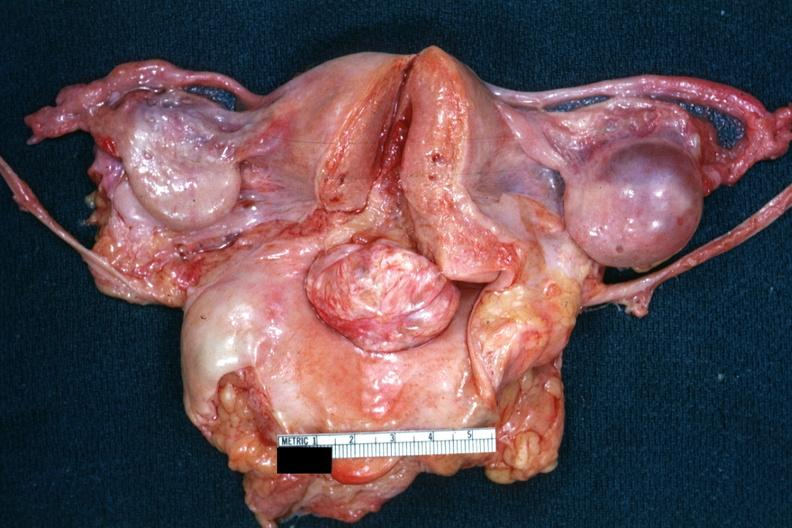does this image show opened uterus and cervix with large cervical myoma protruding into vagina slide is close-up of cut surface of this myoma?
Answer the question using a single word or phrase. Yes 